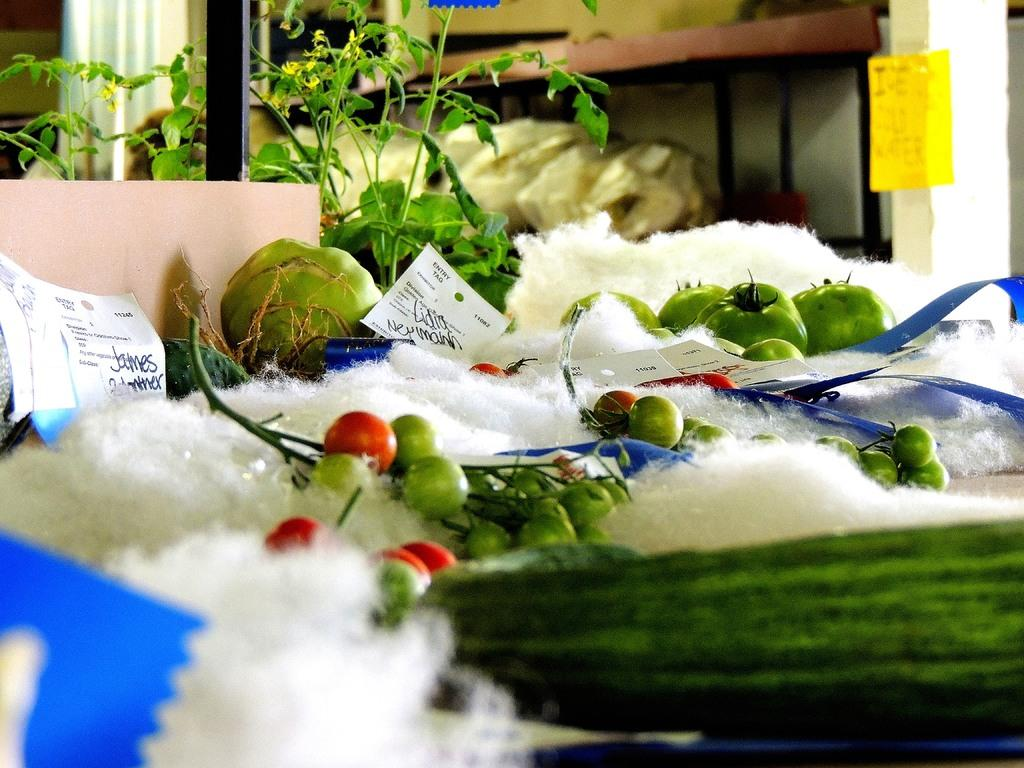What types of objects can be seen in the image? There are objects in the image, including tomatoes. Can you describe the background of the image? The background of the image features objects on a rack. What is located on the left side of the image? There are plants on the left side of the image. Which actor is playing the role of the queen in the image? There are no actors or roles in the image; it features objects, tomatoes, a background with objects on a rack, and plants on the left side. What type of underwear is visible on the tomatoes in the image? There is no underwear present in the image, as it features objects, tomatoes, a background with objects on a rack, and plants on the left side. 